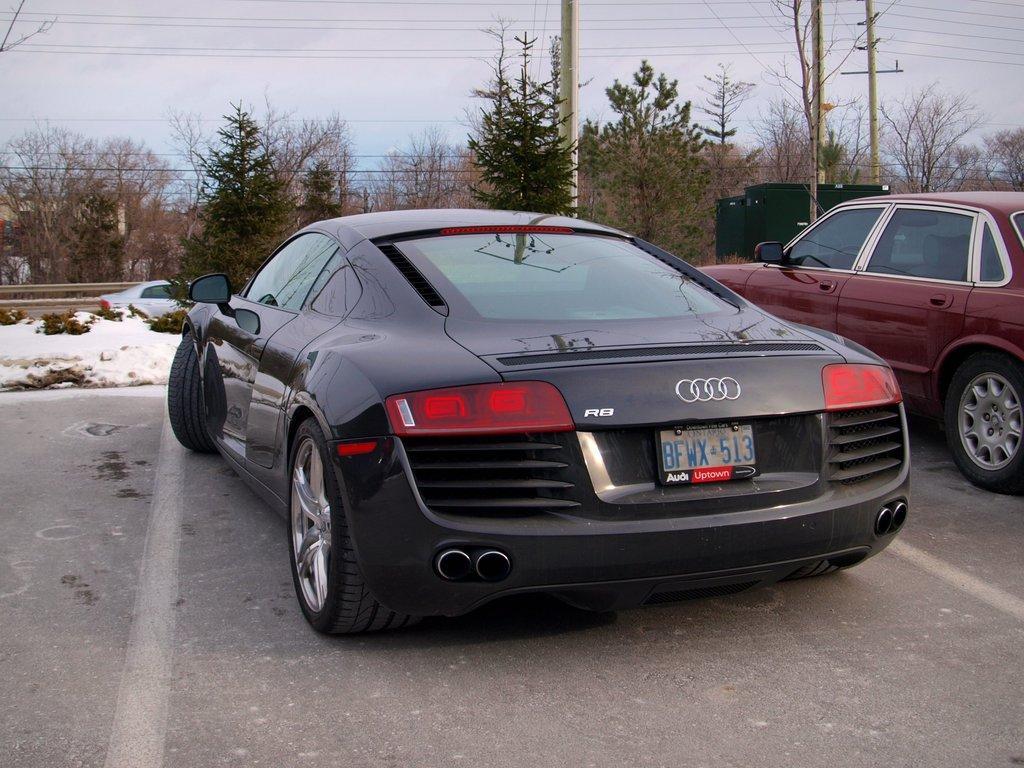Please provide a concise description of this image. There is a black color vehicle parked, near a red color vehicle, in the parking area. In the background, there is a vehicle on the road, near trees, there are poles having electrical lines, there are trees and there are clouds in the blue sky. 